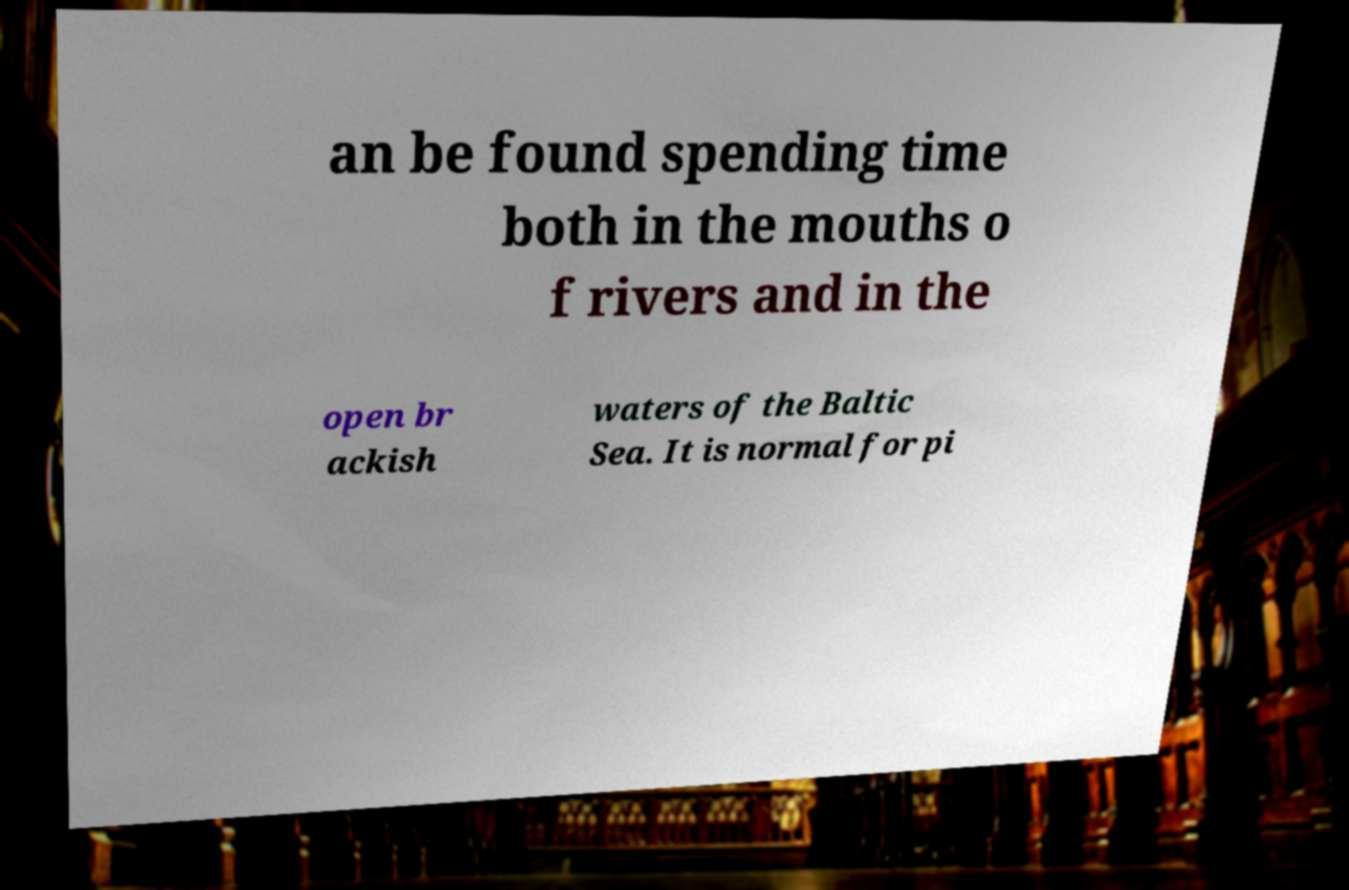There's text embedded in this image that I need extracted. Can you transcribe it verbatim? an be found spending time both in the mouths o f rivers and in the open br ackish waters of the Baltic Sea. It is normal for pi 